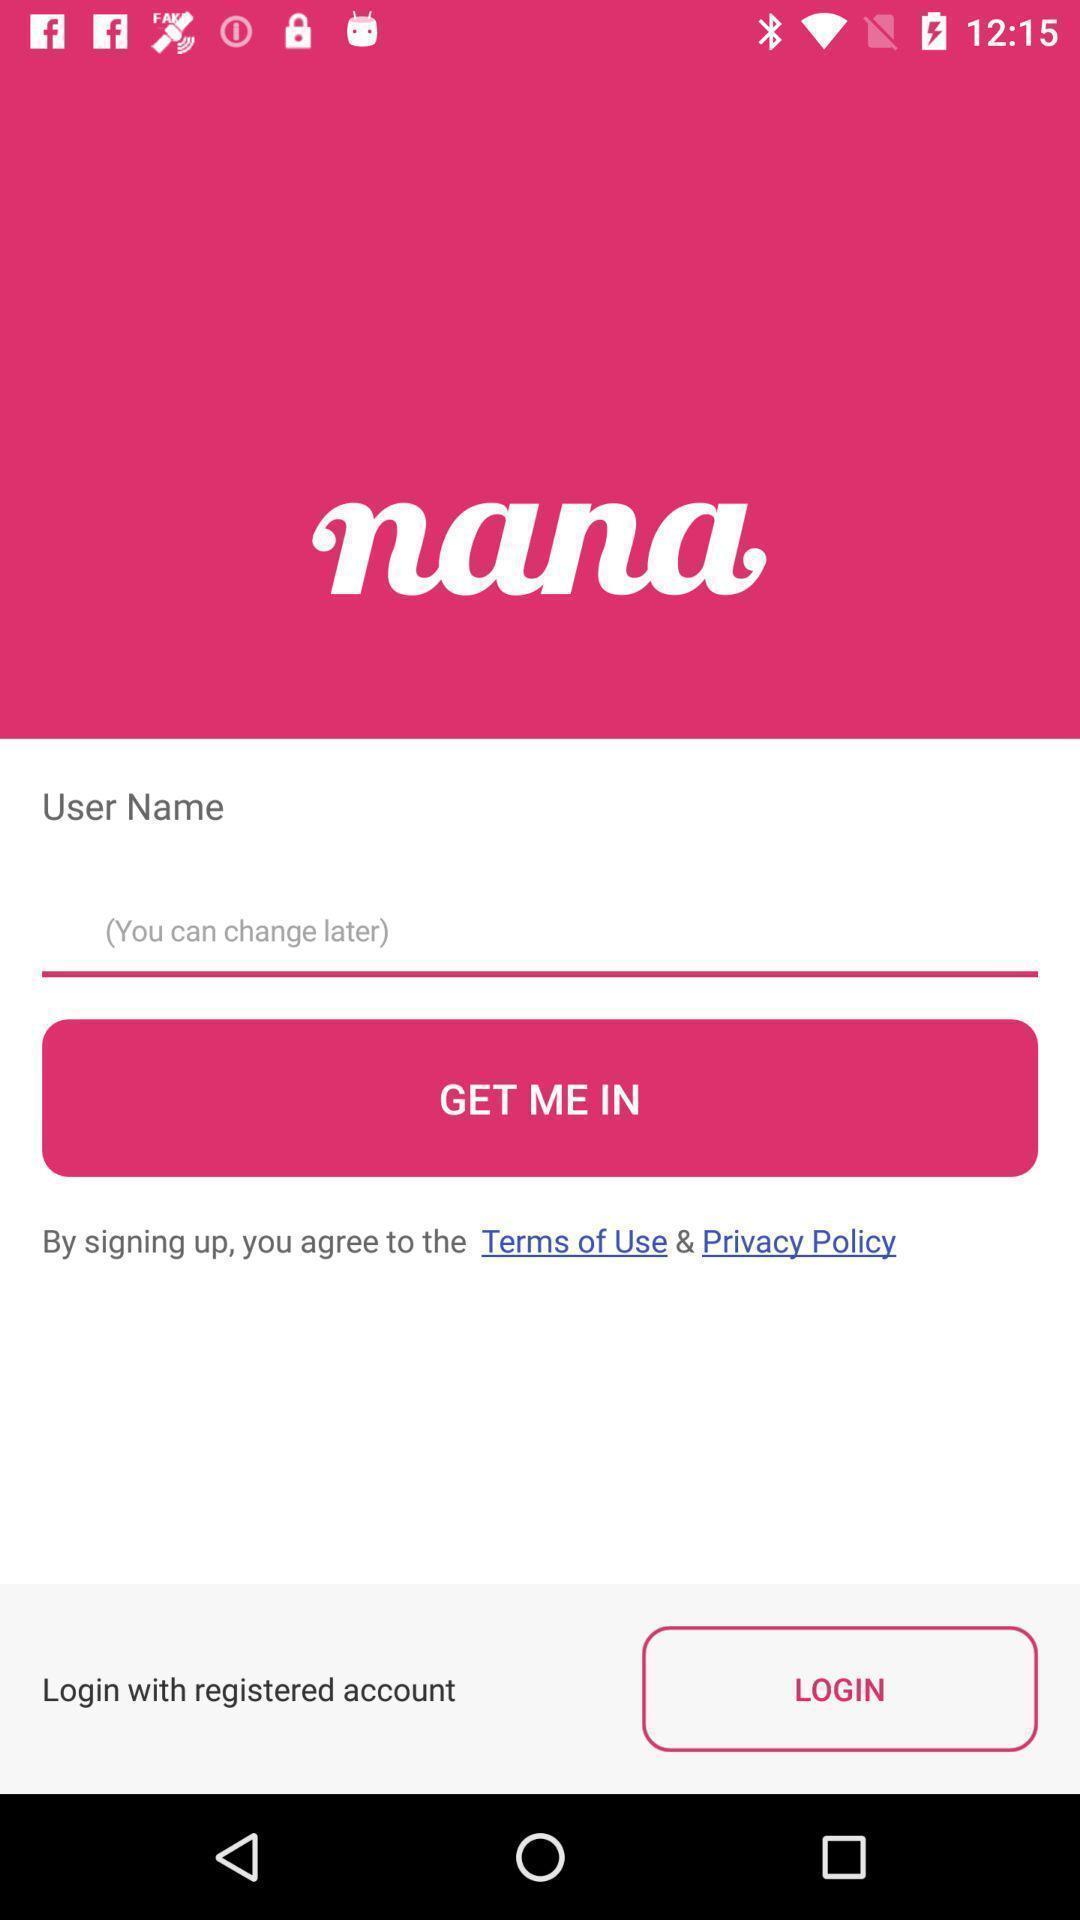Describe the visual elements of this screenshot. Welcome page of a music application. 